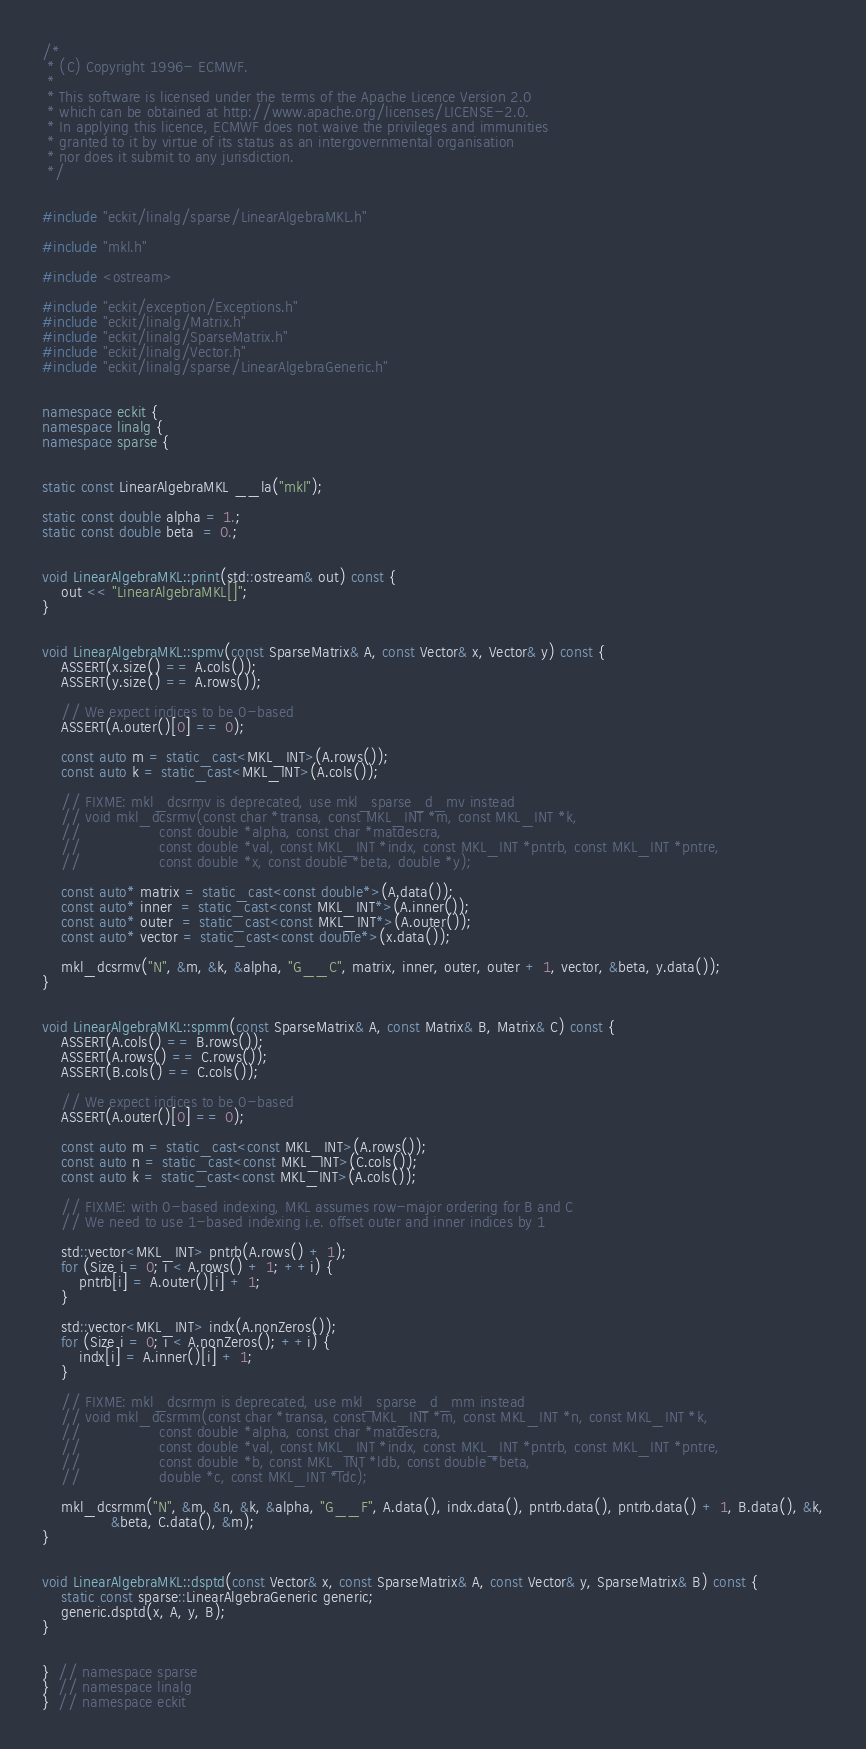Convert code to text. <code><loc_0><loc_0><loc_500><loc_500><_C++_>/*
 * (C) Copyright 1996- ECMWF.
 *
 * This software is licensed under the terms of the Apache Licence Version 2.0
 * which can be obtained at http://www.apache.org/licenses/LICENSE-2.0.
 * In applying this licence, ECMWF does not waive the privileges and immunities
 * granted to it by virtue of its status as an intergovernmental organisation
 * nor does it submit to any jurisdiction.
 */


#include "eckit/linalg/sparse/LinearAlgebraMKL.h"

#include "mkl.h"

#include <ostream>

#include "eckit/exception/Exceptions.h"
#include "eckit/linalg/Matrix.h"
#include "eckit/linalg/SparseMatrix.h"
#include "eckit/linalg/Vector.h"
#include "eckit/linalg/sparse/LinearAlgebraGeneric.h"


namespace eckit {
namespace linalg {
namespace sparse {


static const LinearAlgebraMKL __la("mkl");

static const double alpha = 1.;
static const double beta  = 0.;


void LinearAlgebraMKL::print(std::ostream& out) const {
    out << "LinearAlgebraMKL[]";
}


void LinearAlgebraMKL::spmv(const SparseMatrix& A, const Vector& x, Vector& y) const {
    ASSERT(x.size() == A.cols());
    ASSERT(y.size() == A.rows());

    // We expect indices to be 0-based
    ASSERT(A.outer()[0] == 0);

    const auto m = static_cast<MKL_INT>(A.rows());
    const auto k = static_cast<MKL_INT>(A.cols());

    // FIXME: mkl_dcsrmv is deprecated, use mkl_sparse_d_mv instead
    // void mkl_dcsrmv(const char *transa, const MKL_INT *m, const MKL_INT *k,
    //                 const double *alpha, const char *matdescra,
    //                 const double *val, const MKL_INT *indx, const MKL_INT *pntrb, const MKL_INT *pntre,
    //                 const double *x, const double *beta, double *y);

    const auto* matrix = static_cast<const double*>(A.data());
    const auto* inner  = static_cast<const MKL_INT*>(A.inner());
    const auto* outer  = static_cast<const MKL_INT*>(A.outer());
    const auto* vector = static_cast<const double*>(x.data());

    mkl_dcsrmv("N", &m, &k, &alpha, "G__C", matrix, inner, outer, outer + 1, vector, &beta, y.data());
}


void LinearAlgebraMKL::spmm(const SparseMatrix& A, const Matrix& B, Matrix& C) const {
    ASSERT(A.cols() == B.rows());
    ASSERT(A.rows() == C.rows());
    ASSERT(B.cols() == C.cols());

    // We expect indices to be 0-based
    ASSERT(A.outer()[0] == 0);

    const auto m = static_cast<const MKL_INT>(A.rows());
    const auto n = static_cast<const MKL_INT>(C.cols());
    const auto k = static_cast<const MKL_INT>(A.cols());

    // FIXME: with 0-based indexing, MKL assumes row-major ordering for B and C
    // We need to use 1-based indexing i.e. offset outer and inner indices by 1

    std::vector<MKL_INT> pntrb(A.rows() + 1);
    for (Size i = 0; i < A.rows() + 1; ++i) {
        pntrb[i] = A.outer()[i] + 1;
    }

    std::vector<MKL_INT> indx(A.nonZeros());
    for (Size i = 0; i < A.nonZeros(); ++i) {
        indx[i] = A.inner()[i] + 1;
    }

    // FIXME: mkl_dcsrmm is deprecated, use mkl_sparse_d_mm instead
    // void mkl_dcsrmm(const char *transa, const MKL_INT *m, const MKL_INT *n, const MKL_INT *k,
    //                 const double *alpha, const char *matdescra,
    //                 const double *val, const MKL_INT *indx, const MKL_INT *pntrb, const MKL_INT *pntre,
    //                 const double *b, const MKL_INT *ldb, const double *beta,
    //                 double *c, const MKL_INT *ldc);

    mkl_dcsrmm("N", &m, &n, &k, &alpha, "G__F", A.data(), indx.data(), pntrb.data(), pntrb.data() + 1, B.data(), &k,
               &beta, C.data(), &m);
}


void LinearAlgebraMKL::dsptd(const Vector& x, const SparseMatrix& A, const Vector& y, SparseMatrix& B) const {
    static const sparse::LinearAlgebraGeneric generic;
    generic.dsptd(x, A, y, B);
}


}  // namespace sparse
}  // namespace linalg
}  // namespace eckit
</code> 